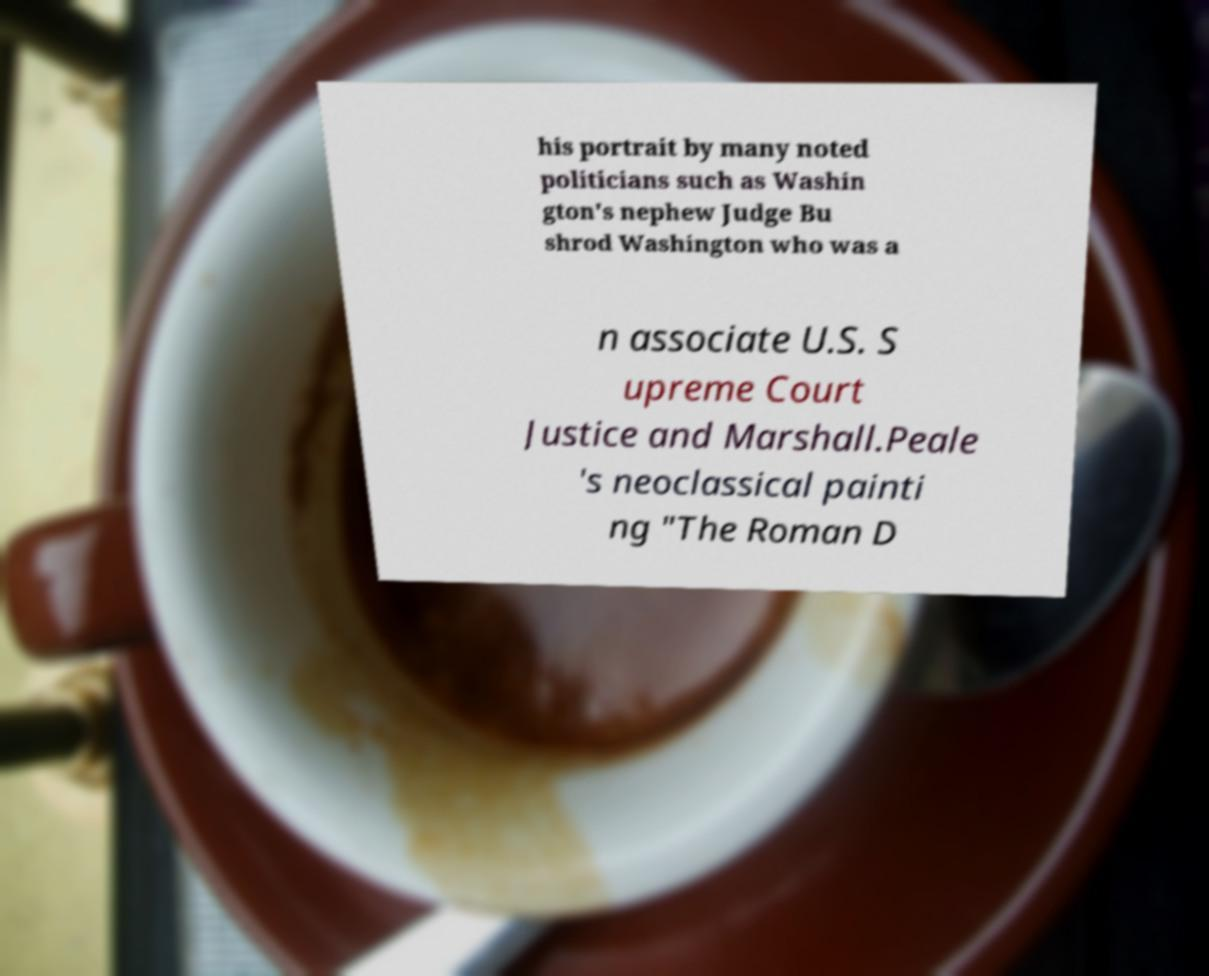I need the written content from this picture converted into text. Can you do that? his portrait by many noted politicians such as Washin gton's nephew Judge Bu shrod Washington who was a n associate U.S. S upreme Court Justice and Marshall.Peale 's neoclassical painti ng "The Roman D 